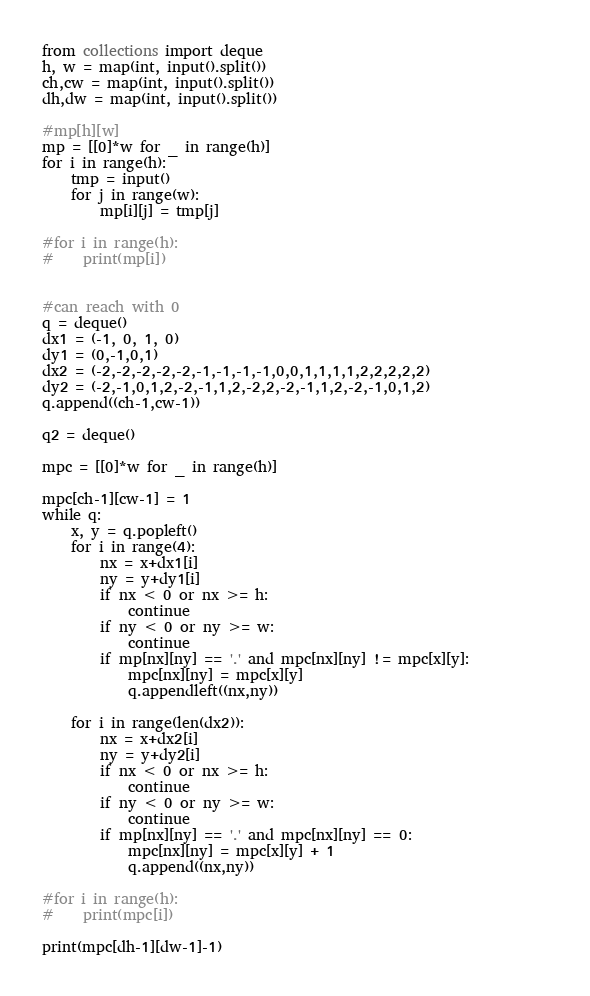Convert code to text. <code><loc_0><loc_0><loc_500><loc_500><_Python_>from collections import deque
h, w = map(int, input().split())
ch,cw = map(int, input().split())
dh,dw = map(int, input().split())

#mp[h][w]
mp = [[0]*w for _ in range(h)]
for i in range(h):
    tmp = input()
    for j in range(w):
        mp[i][j] = tmp[j]

#for i in range(h):
#    print(mp[i])


#can reach with 0
q = deque()
dx1 = (-1, 0, 1, 0)
dy1 = (0,-1,0,1)
dx2 = (-2,-2,-2,-2,-2,-1,-1,-1,-1,0,0,1,1,1,1,2,2,2,2,2)
dy2 = (-2,-1,0,1,2,-2,-1,1,2,-2,2,-2,-1,1,2,-2,-1,0,1,2)
q.append((ch-1,cw-1))

q2 = deque()

mpc = [[0]*w for _ in range(h)]

mpc[ch-1][cw-1] = 1
while q:
    x, y = q.popleft()
    for i in range(4): 
        nx = x+dx1[i]
        ny = y+dy1[i]
        if nx < 0 or nx >= h:
            continue
        if ny < 0 or ny >= w:
            continue
        if mp[nx][ny] == '.' and mpc[nx][ny] != mpc[x][y]:           
            mpc[nx][ny] = mpc[x][y]
            q.appendleft((nx,ny))

    for i in range(len(dx2)):
        nx = x+dx2[i]
        ny = y+dy2[i]
        if nx < 0 or nx >= h:
            continue
        if ny < 0 or ny >= w:
            continue
        if mp[nx][ny] == '.' and mpc[nx][ny] == 0:       
            mpc[nx][ny] = mpc[x][y] + 1
            q.append((nx,ny))
    
#for i in range(h):
#    print(mpc[i])

print(mpc[dh-1][dw-1]-1)

</code> 